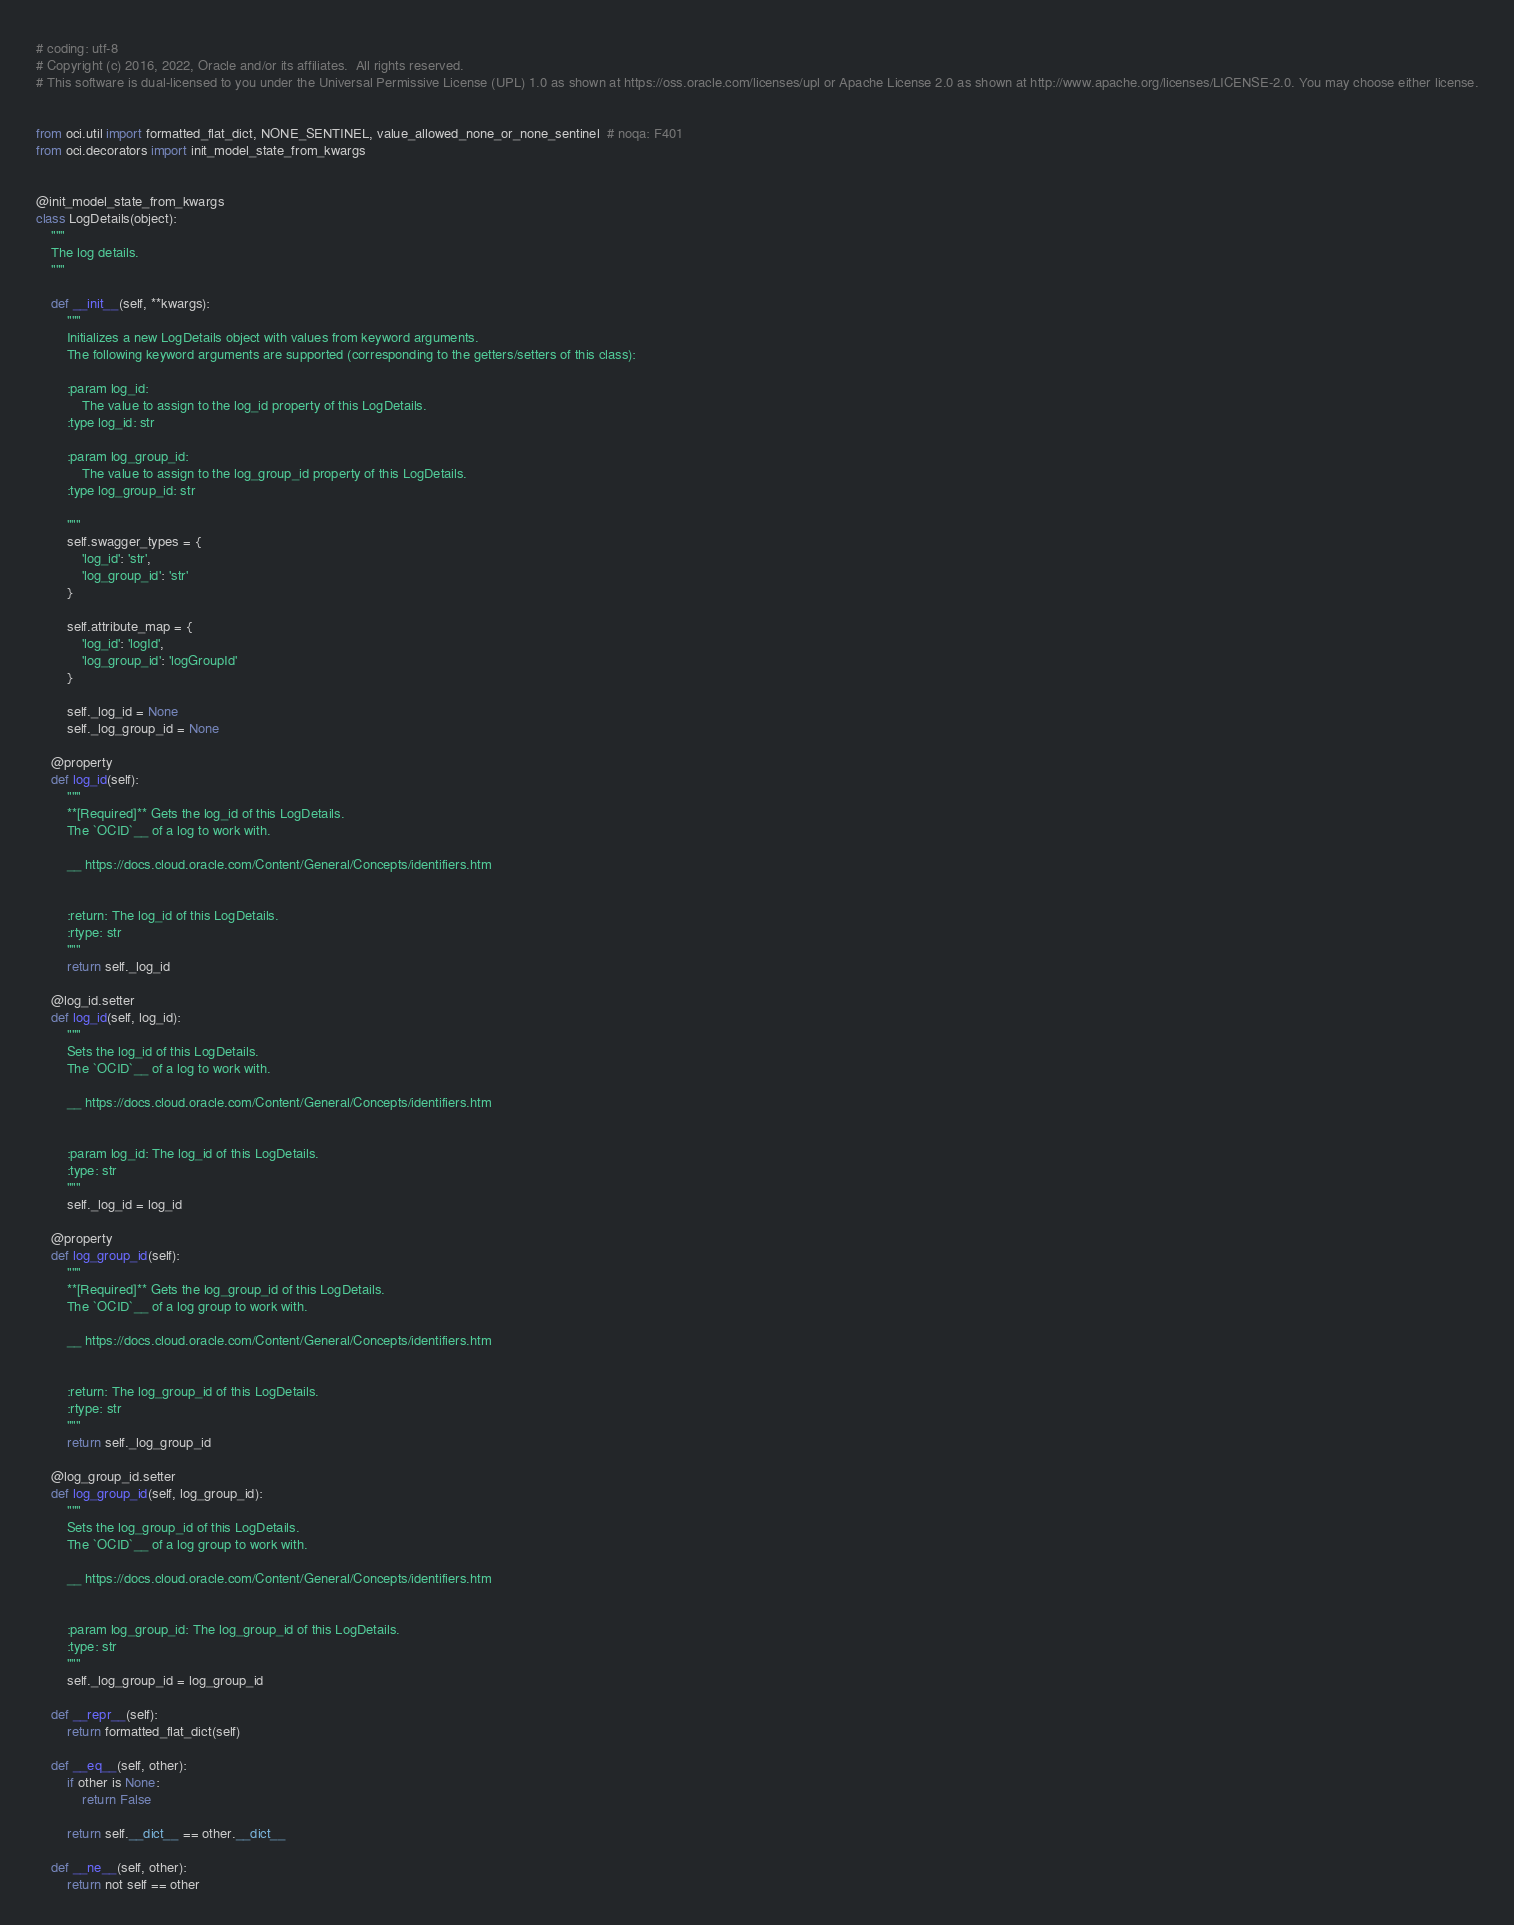<code> <loc_0><loc_0><loc_500><loc_500><_Python_># coding: utf-8
# Copyright (c) 2016, 2022, Oracle and/or its affiliates.  All rights reserved.
# This software is dual-licensed to you under the Universal Permissive License (UPL) 1.0 as shown at https://oss.oracle.com/licenses/upl or Apache License 2.0 as shown at http://www.apache.org/licenses/LICENSE-2.0. You may choose either license.


from oci.util import formatted_flat_dict, NONE_SENTINEL, value_allowed_none_or_none_sentinel  # noqa: F401
from oci.decorators import init_model_state_from_kwargs


@init_model_state_from_kwargs
class LogDetails(object):
    """
    The log details.
    """

    def __init__(self, **kwargs):
        """
        Initializes a new LogDetails object with values from keyword arguments.
        The following keyword arguments are supported (corresponding to the getters/setters of this class):

        :param log_id:
            The value to assign to the log_id property of this LogDetails.
        :type log_id: str

        :param log_group_id:
            The value to assign to the log_group_id property of this LogDetails.
        :type log_group_id: str

        """
        self.swagger_types = {
            'log_id': 'str',
            'log_group_id': 'str'
        }

        self.attribute_map = {
            'log_id': 'logId',
            'log_group_id': 'logGroupId'
        }

        self._log_id = None
        self._log_group_id = None

    @property
    def log_id(self):
        """
        **[Required]** Gets the log_id of this LogDetails.
        The `OCID`__ of a log to work with.

        __ https://docs.cloud.oracle.com/Content/General/Concepts/identifiers.htm


        :return: The log_id of this LogDetails.
        :rtype: str
        """
        return self._log_id

    @log_id.setter
    def log_id(self, log_id):
        """
        Sets the log_id of this LogDetails.
        The `OCID`__ of a log to work with.

        __ https://docs.cloud.oracle.com/Content/General/Concepts/identifiers.htm


        :param log_id: The log_id of this LogDetails.
        :type: str
        """
        self._log_id = log_id

    @property
    def log_group_id(self):
        """
        **[Required]** Gets the log_group_id of this LogDetails.
        The `OCID`__ of a log group to work with.

        __ https://docs.cloud.oracle.com/Content/General/Concepts/identifiers.htm


        :return: The log_group_id of this LogDetails.
        :rtype: str
        """
        return self._log_group_id

    @log_group_id.setter
    def log_group_id(self, log_group_id):
        """
        Sets the log_group_id of this LogDetails.
        The `OCID`__ of a log group to work with.

        __ https://docs.cloud.oracle.com/Content/General/Concepts/identifiers.htm


        :param log_group_id: The log_group_id of this LogDetails.
        :type: str
        """
        self._log_group_id = log_group_id

    def __repr__(self):
        return formatted_flat_dict(self)

    def __eq__(self, other):
        if other is None:
            return False

        return self.__dict__ == other.__dict__

    def __ne__(self, other):
        return not self == other
</code> 